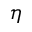Convert formula to latex. <formula><loc_0><loc_0><loc_500><loc_500>\eta</formula> 